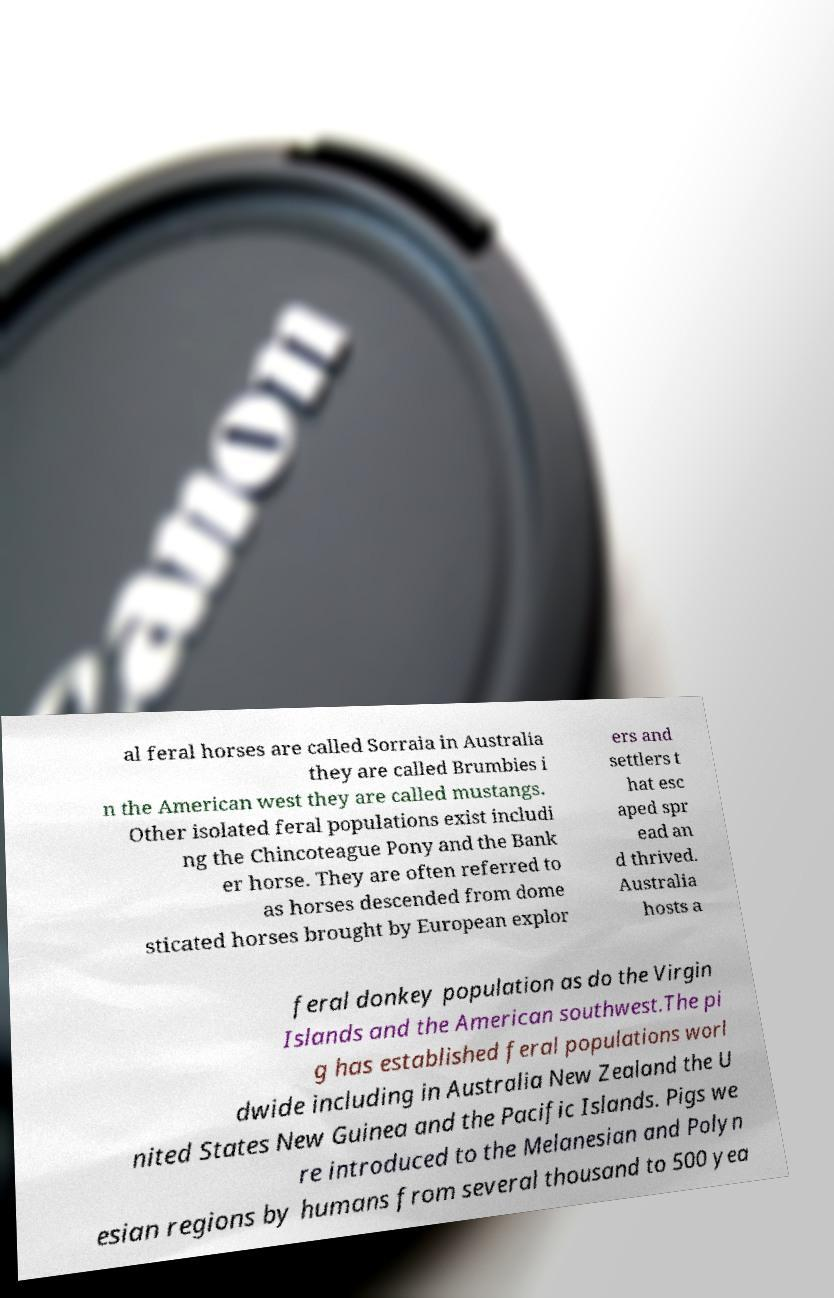There's text embedded in this image that I need extracted. Can you transcribe it verbatim? al feral horses are called Sorraia in Australia they are called Brumbies i n the American west they are called mustangs. Other isolated feral populations exist includi ng the Chincoteague Pony and the Bank er horse. They are often referred to as horses descended from dome sticated horses brought by European explor ers and settlers t hat esc aped spr ead an d thrived. Australia hosts a feral donkey population as do the Virgin Islands and the American southwest.The pi g has established feral populations worl dwide including in Australia New Zealand the U nited States New Guinea and the Pacific Islands. Pigs we re introduced to the Melanesian and Polyn esian regions by humans from several thousand to 500 yea 